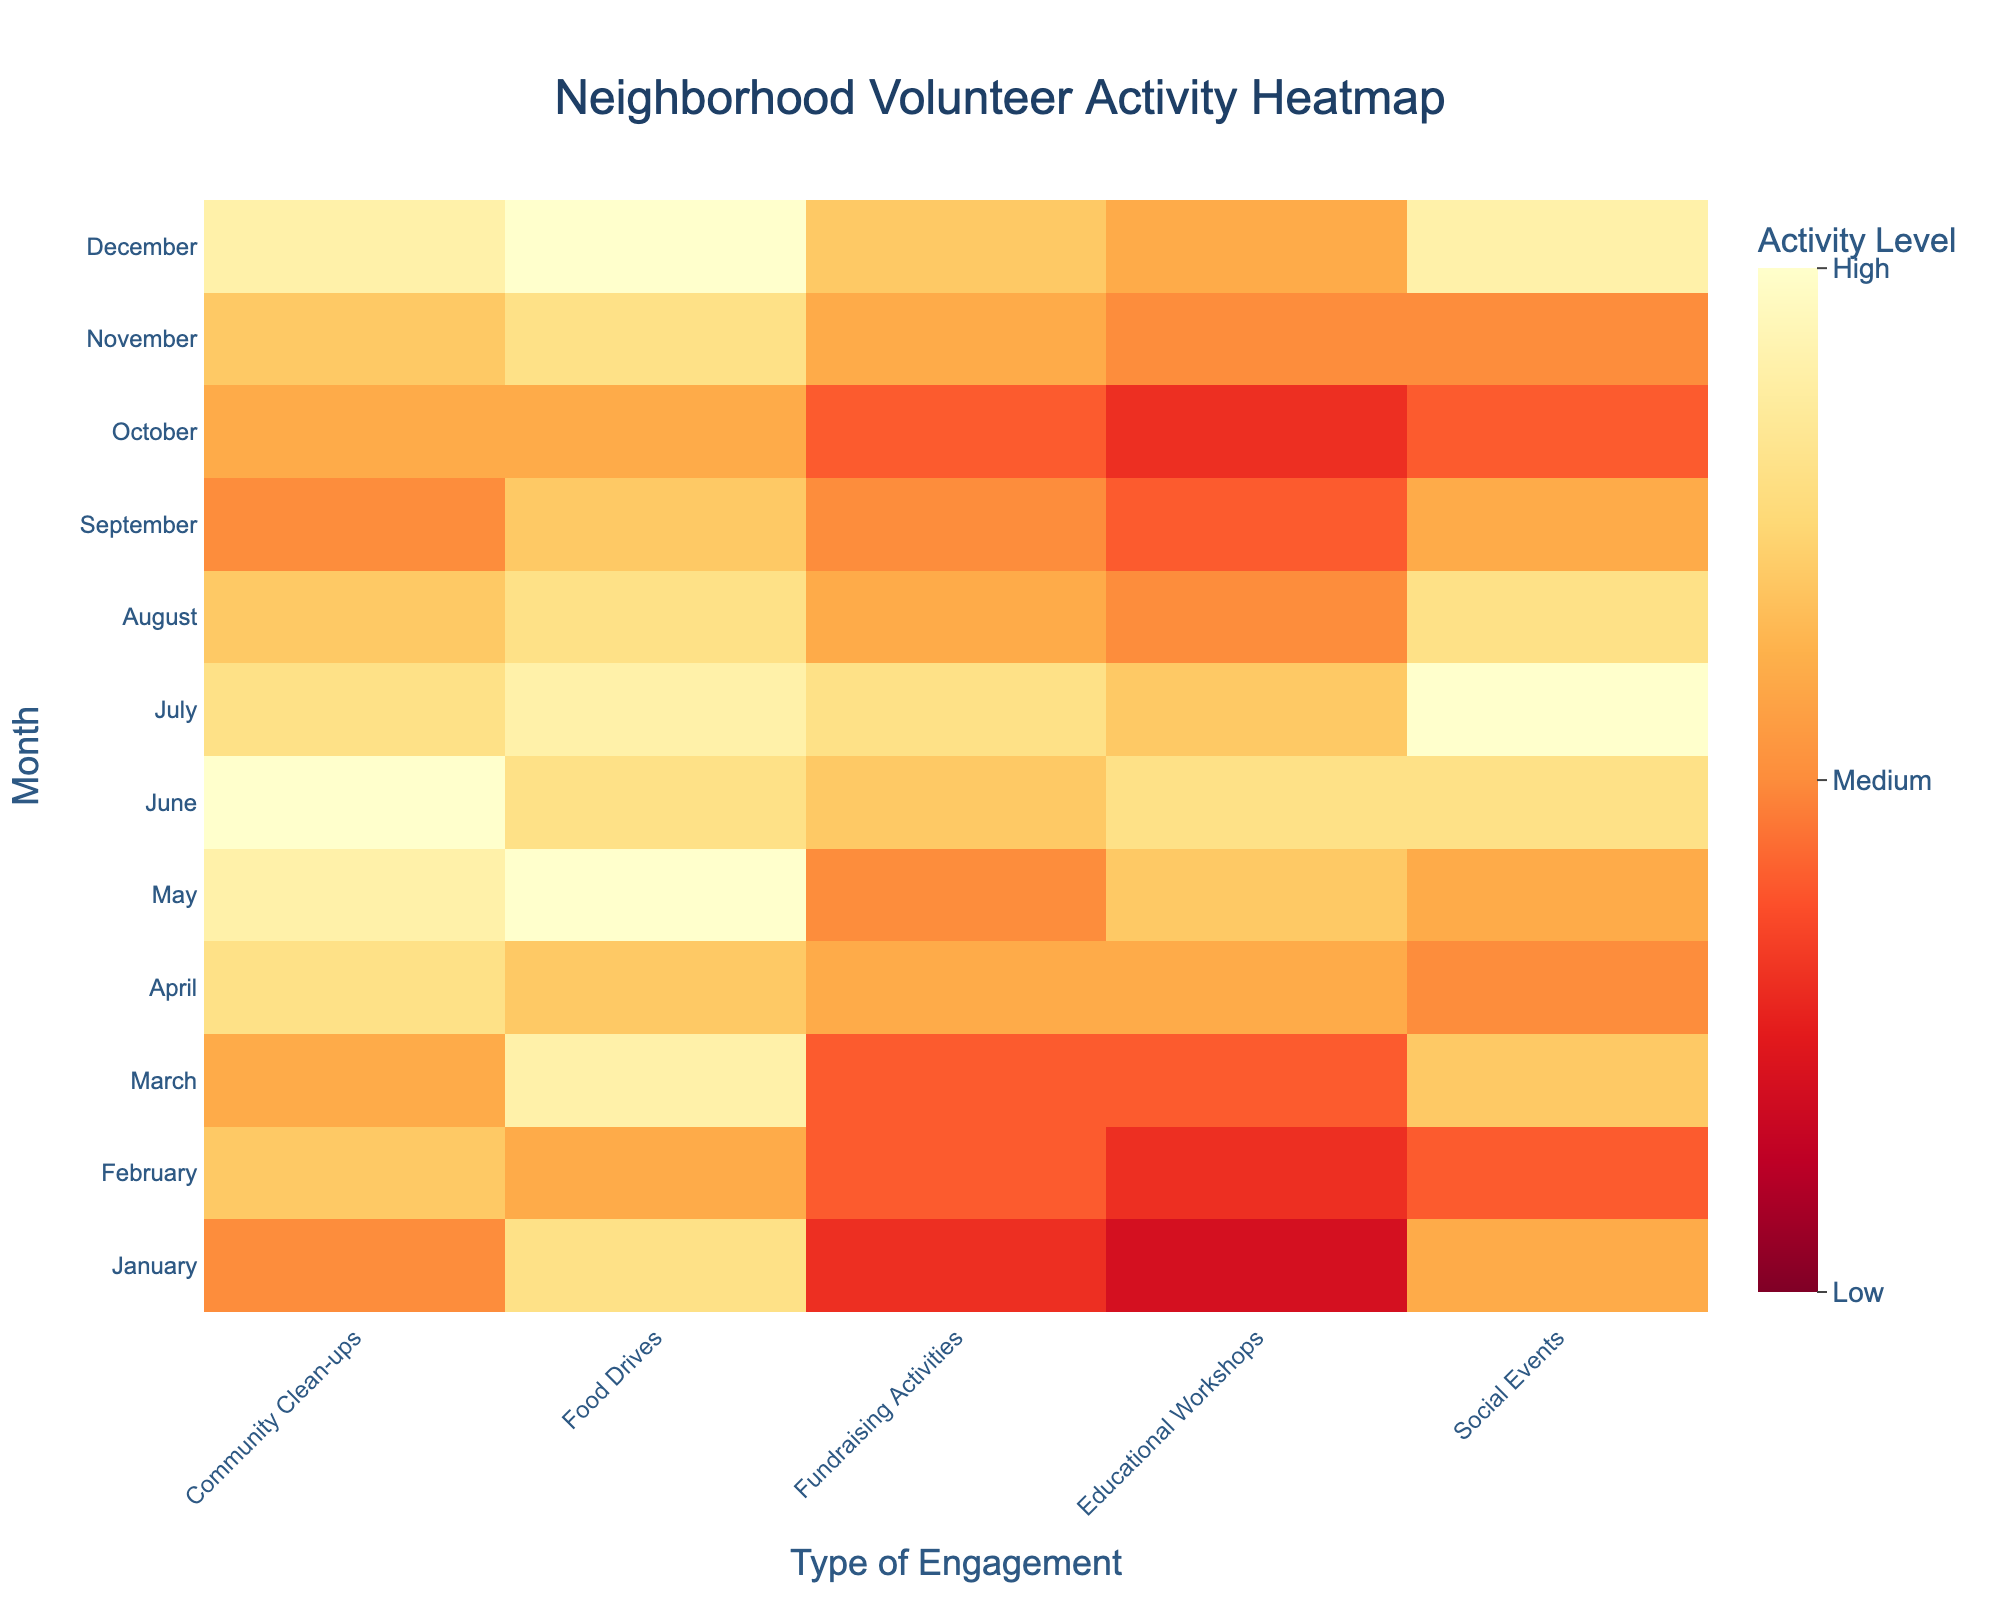What's the title of the heatmap? The title is prominently displayed at the top of the heatmap.
Answer: Neighborhood Volunteer Activity Heatmap What are the months with the highest level of fundraising activities? Look for the darkest colors in the "Fundraising Activities" column.
Answer: June, July, December How many types of engagement are tracked in the heatmap? Count the number of columns excluding the 'Month' column.
Answer: Five Which month had the most community clean-ups? Identify the darkest cell in the "Community Clean-ups" column.
Answer: June Find the month with the lowest number of social events. Identify the lightest cell in the "Social Events" column.
Answer: February, October What is the average activity level for educational workshops in March? The value for educational workshops in March is already given.
Answer: 4 Which type of engagement shows the highest variation in activity levels across months? Compare the range of colors across each engagement type.
Answer: Social Events (ranging from light to dark cells) In which month does the highest activity level occur, and for which type of engagement? Find the darkest cell in the entire heatmap and note its row (month) and column (engagement type).
Answer: July for Social Events Are food drive activity levels generally higher or lower in the second half of the year (July-December) compared to the first half (January-June)? Compare the color intensity between the two halves of the year in the "Food Drives" column.
Answer: Lower in the second half Which month has the most balanced (similar) activity levels across all types of engagement? Look for a month with similar color intensities across all activity types.
Answer: April 